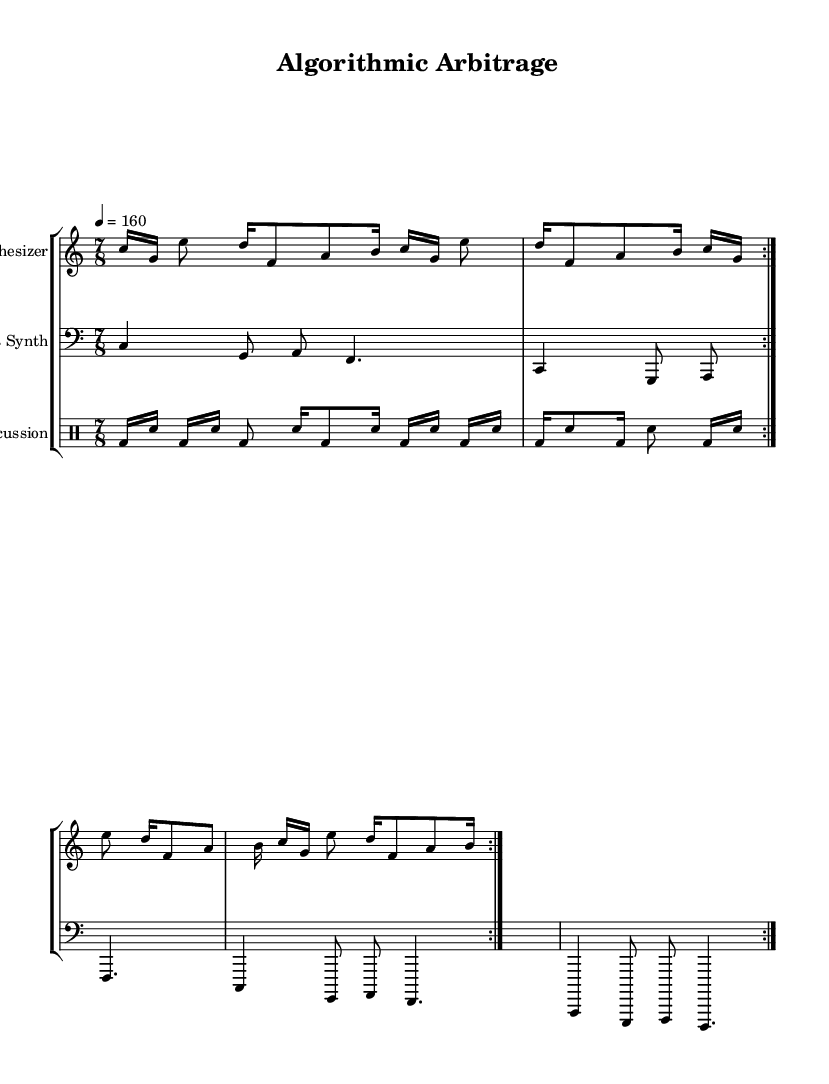What is the key signature of this music? The key signature is C major, which has no sharps or flats.
Answer: C major What is the time signature of this music? The time signature is indicated as 7/8, meaning there are seven eighth-note beats in each measure.
Answer: 7/8 What is the tempo marking given in the sheet music? The tempo marking is stated as 4 equals 160, indicating the speed at which the piece is to be performed.
Answer: 160 How many times is the synth melody repeated? The synth melody section is marked with a repeat indication and is repeated two times.
Answer: 2 What type of synthesis is used for the melody? The piece is designated for a synthesizer, which indicates that the melodic component uses synthesized sounds.
Answer: Synthesizer Which instrument plays the bass line? The bass line is designated for a bass synth, which specifies the use of a synthesizer in a lower register.
Answer: Bass Synth What is the rhythmic structure of the percussion part? The percussion part features a glitch-style pattern with irregularities, typically characterized by rapid, unexpected accents and unpredictable timing.
Answer: Glitch Percussion 